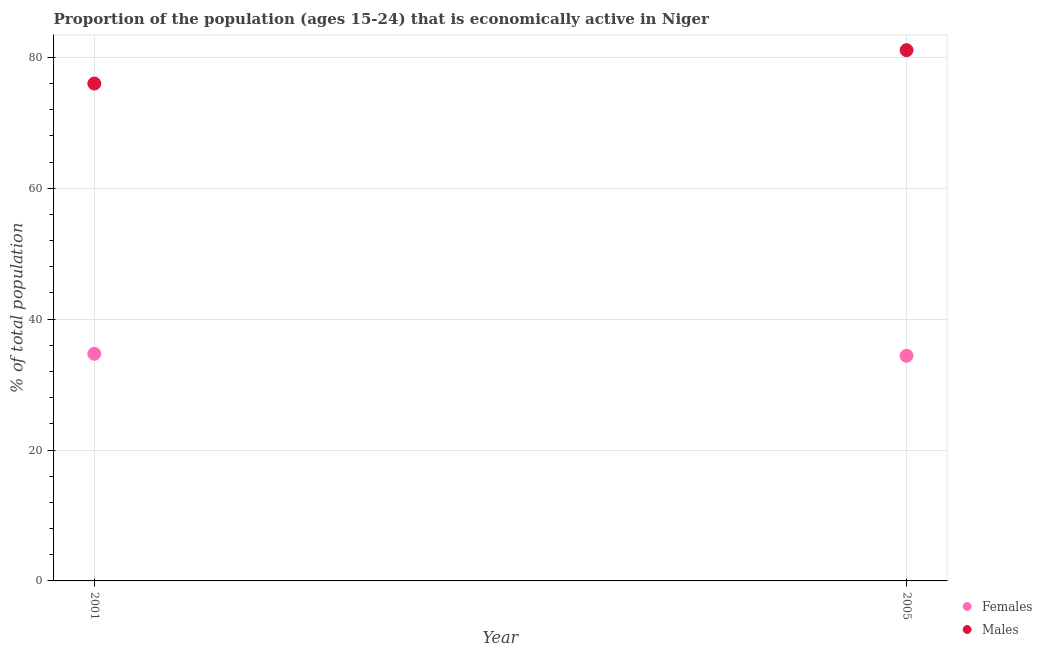How many different coloured dotlines are there?
Ensure brevity in your answer.  2. What is the percentage of economically active female population in 2001?
Make the answer very short. 34.7. Across all years, what is the maximum percentage of economically active female population?
Provide a short and direct response. 34.7. Across all years, what is the minimum percentage of economically active female population?
Ensure brevity in your answer.  34.4. In which year was the percentage of economically active male population maximum?
Your response must be concise. 2005. What is the total percentage of economically active male population in the graph?
Give a very brief answer. 157.1. What is the difference between the percentage of economically active male population in 2001 and that in 2005?
Offer a very short reply. -5.1. What is the difference between the percentage of economically active male population in 2001 and the percentage of economically active female population in 2005?
Offer a terse response. 41.6. What is the average percentage of economically active male population per year?
Your answer should be very brief. 78.55. In the year 2005, what is the difference between the percentage of economically active female population and percentage of economically active male population?
Your answer should be compact. -46.7. What is the ratio of the percentage of economically active female population in 2001 to that in 2005?
Your answer should be compact. 1.01. Is the percentage of economically active male population in 2001 less than that in 2005?
Give a very brief answer. Yes. In how many years, is the percentage of economically active male population greater than the average percentage of economically active male population taken over all years?
Your answer should be very brief. 1. Is the percentage of economically active female population strictly greater than the percentage of economically active male population over the years?
Ensure brevity in your answer.  No. What is the difference between two consecutive major ticks on the Y-axis?
Provide a succinct answer. 20. Does the graph contain grids?
Your response must be concise. Yes. How many legend labels are there?
Your response must be concise. 2. How are the legend labels stacked?
Ensure brevity in your answer.  Vertical. What is the title of the graph?
Your answer should be very brief. Proportion of the population (ages 15-24) that is economically active in Niger. What is the label or title of the Y-axis?
Give a very brief answer. % of total population. What is the % of total population of Females in 2001?
Ensure brevity in your answer.  34.7. What is the % of total population of Females in 2005?
Your answer should be compact. 34.4. What is the % of total population in Males in 2005?
Make the answer very short. 81.1. Across all years, what is the maximum % of total population of Females?
Offer a terse response. 34.7. Across all years, what is the maximum % of total population in Males?
Provide a short and direct response. 81.1. Across all years, what is the minimum % of total population in Females?
Provide a succinct answer. 34.4. What is the total % of total population of Females in the graph?
Provide a short and direct response. 69.1. What is the total % of total population in Males in the graph?
Offer a very short reply. 157.1. What is the difference between the % of total population in Males in 2001 and that in 2005?
Your answer should be very brief. -5.1. What is the difference between the % of total population in Females in 2001 and the % of total population in Males in 2005?
Give a very brief answer. -46.4. What is the average % of total population in Females per year?
Ensure brevity in your answer.  34.55. What is the average % of total population of Males per year?
Give a very brief answer. 78.55. In the year 2001, what is the difference between the % of total population of Females and % of total population of Males?
Provide a short and direct response. -41.3. In the year 2005, what is the difference between the % of total population in Females and % of total population in Males?
Ensure brevity in your answer.  -46.7. What is the ratio of the % of total population of Females in 2001 to that in 2005?
Your response must be concise. 1.01. What is the ratio of the % of total population in Males in 2001 to that in 2005?
Make the answer very short. 0.94. What is the difference between the highest and the second highest % of total population in Females?
Make the answer very short. 0.3. What is the difference between the highest and the second highest % of total population of Males?
Keep it short and to the point. 5.1. What is the difference between the highest and the lowest % of total population of Males?
Give a very brief answer. 5.1. 